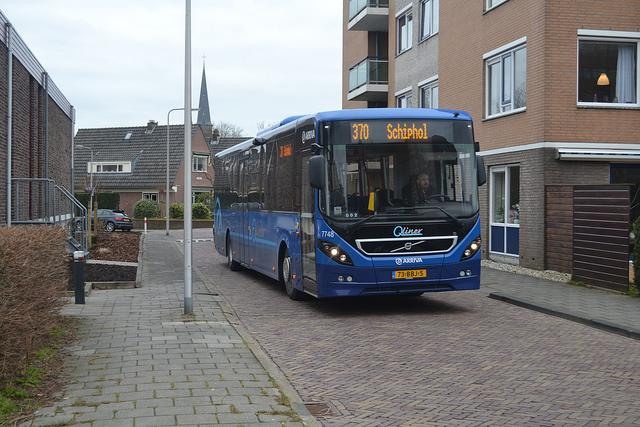What kind of problem is likely to be experienced by the apartment residents?

Choices:
A) noise
B) pollution
C) graffiti
D) burglary noise 